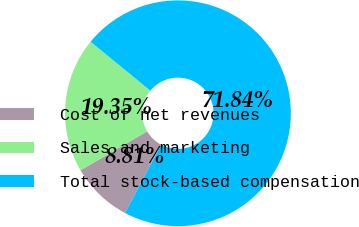<chart> <loc_0><loc_0><loc_500><loc_500><pie_chart><fcel>Cost of net revenues<fcel>Sales and marketing<fcel>Total stock-based compensation<nl><fcel>8.81%<fcel>19.35%<fcel>71.84%<nl></chart> 